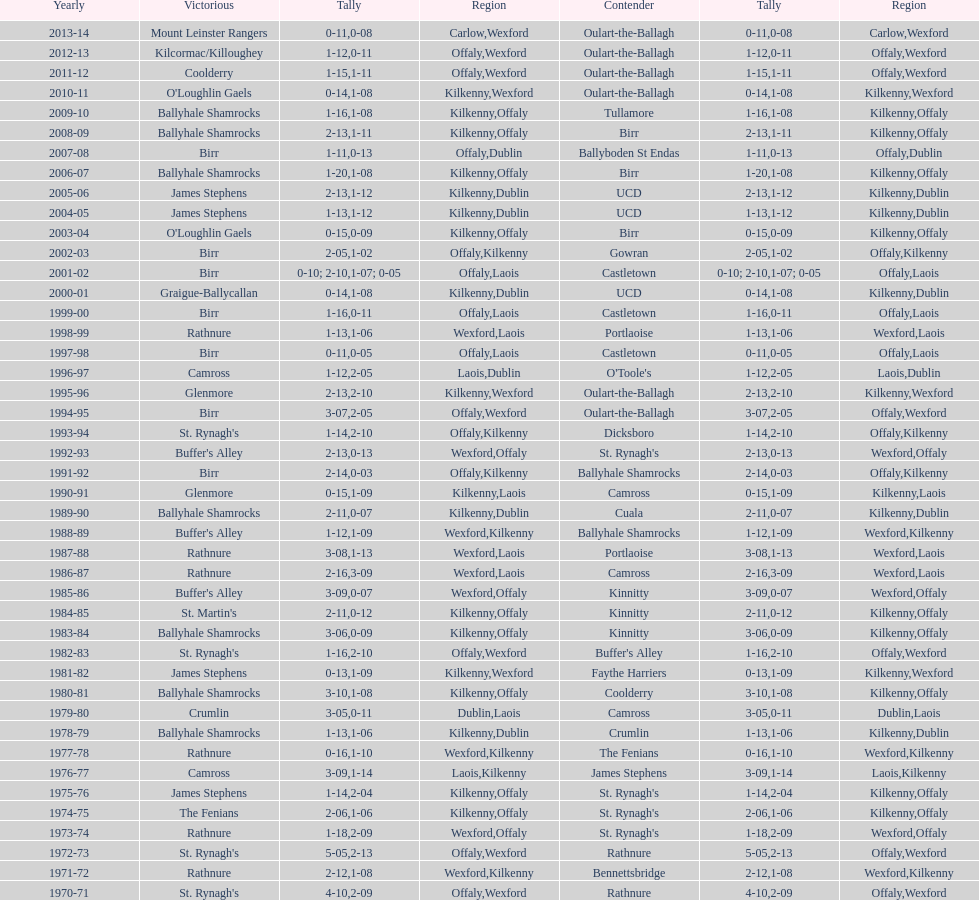In what most recent season was the leinster senior club hurling championships decided by a point difference of under 11? 2007-08. 